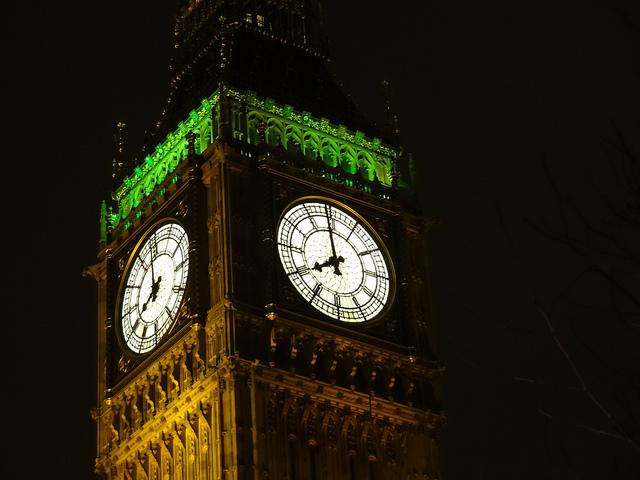Is the tower tall?
Keep it brief. Yes. Does the clock have numbers?
Be succinct. No. What time is it?
Keep it brief. 8:00. What color is that clock?
Write a very short answer. White. 